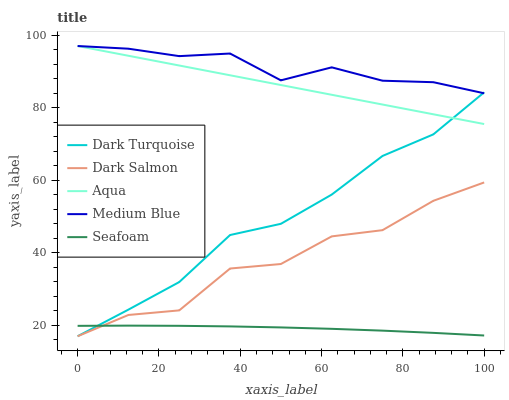Does Dark Turquoise have the minimum area under the curve?
Answer yes or no. No. Does Dark Turquoise have the maximum area under the curve?
Answer yes or no. No. Is Dark Turquoise the smoothest?
Answer yes or no. No. Is Dark Turquoise the roughest?
Answer yes or no. No. Does Aqua have the lowest value?
Answer yes or no. No. Does Dark Turquoise have the highest value?
Answer yes or no. No. Is Seafoam less than Medium Blue?
Answer yes or no. Yes. Is Aqua greater than Dark Salmon?
Answer yes or no. Yes. Does Seafoam intersect Medium Blue?
Answer yes or no. No. 